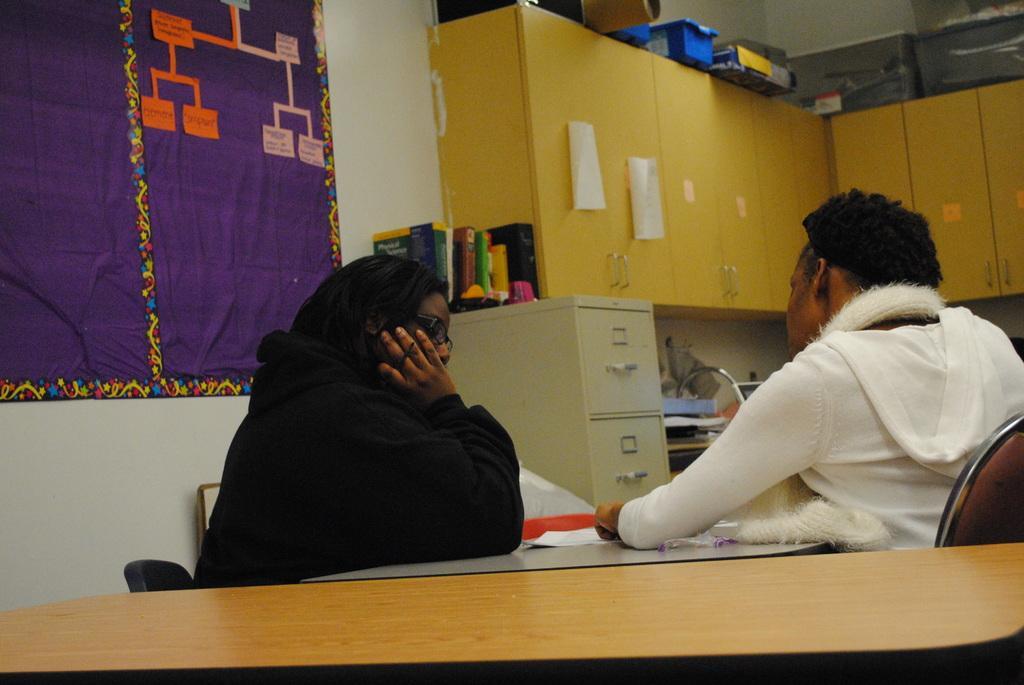How would you summarize this image in a sentence or two? In this image we can see a man and a woman sitting on the chairs beside a table containing some papers on it. We can also see some books, containers, objects and some papers placed on the cupboards, a cloth on a wall and some objects placed in a shelf. 